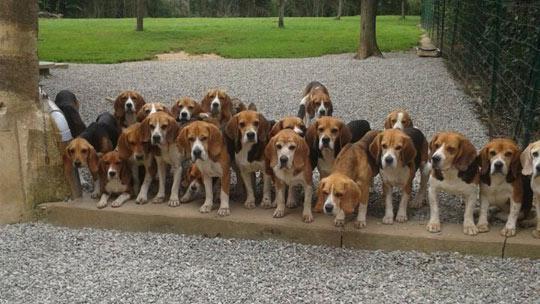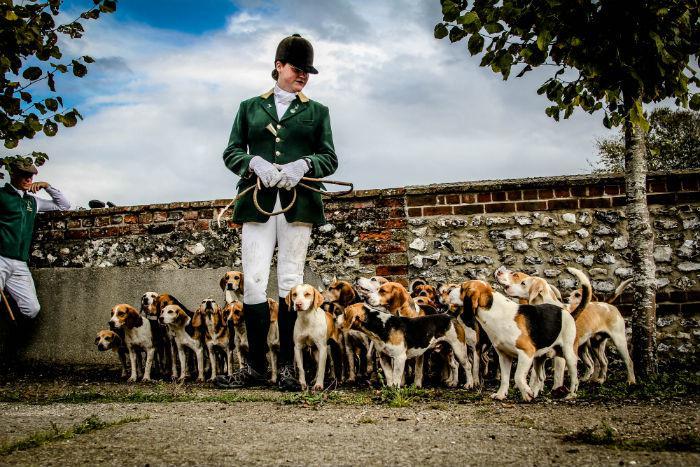The first image is the image on the left, the second image is the image on the right. Evaluate the accuracy of this statement regarding the images: "An image shows a horizontal row of beagle hounds, with no humans present.". Is it true? Answer yes or no. Yes. The first image is the image on the left, the second image is the image on the right. Evaluate the accuracy of this statement regarding the images: "The dogs in the left image are walking toward the camera in a large group.". Is it true? Answer yes or no. No. 